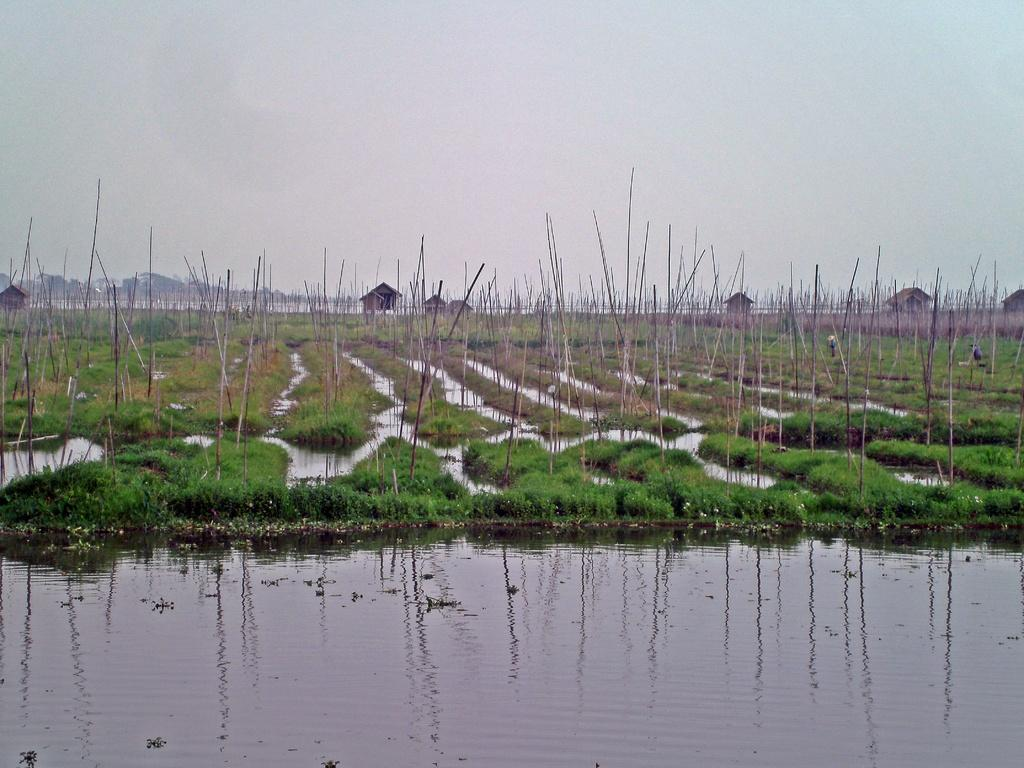What type of water feature is present in the image? There is a canal in the image. What can be seen in the distance behind the canal? There are fields in the background of the image. What structures are present in the fields? There are wooden poles and houses in the fields. Are there any ghosts visible in the image? There are no ghosts present in the image. How are the wooden poles being used to sort the fields? The wooden poles are not being used to sort the fields; they are simply standing in the fields. 